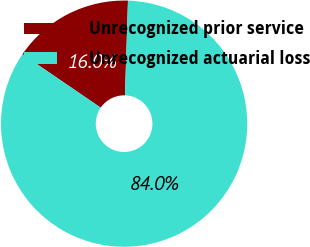Convert chart to OTSL. <chart><loc_0><loc_0><loc_500><loc_500><pie_chart><fcel>Unrecognized prior service<fcel>Unrecognized actuarial loss<nl><fcel>15.96%<fcel>84.04%<nl></chart> 